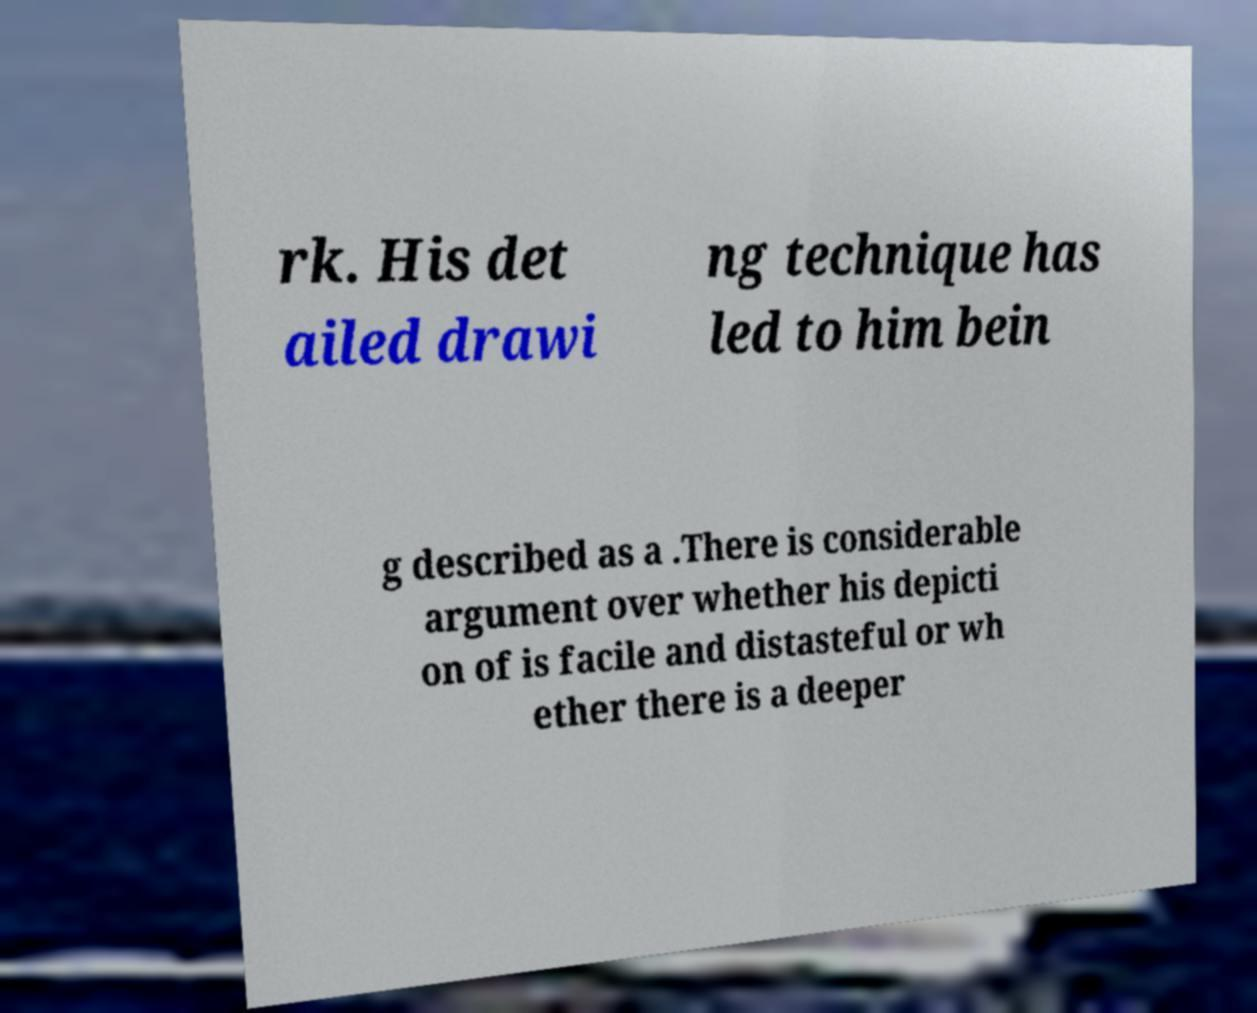I need the written content from this picture converted into text. Can you do that? rk. His det ailed drawi ng technique has led to him bein g described as a .There is considerable argument over whether his depicti on of is facile and distasteful or wh ether there is a deeper 